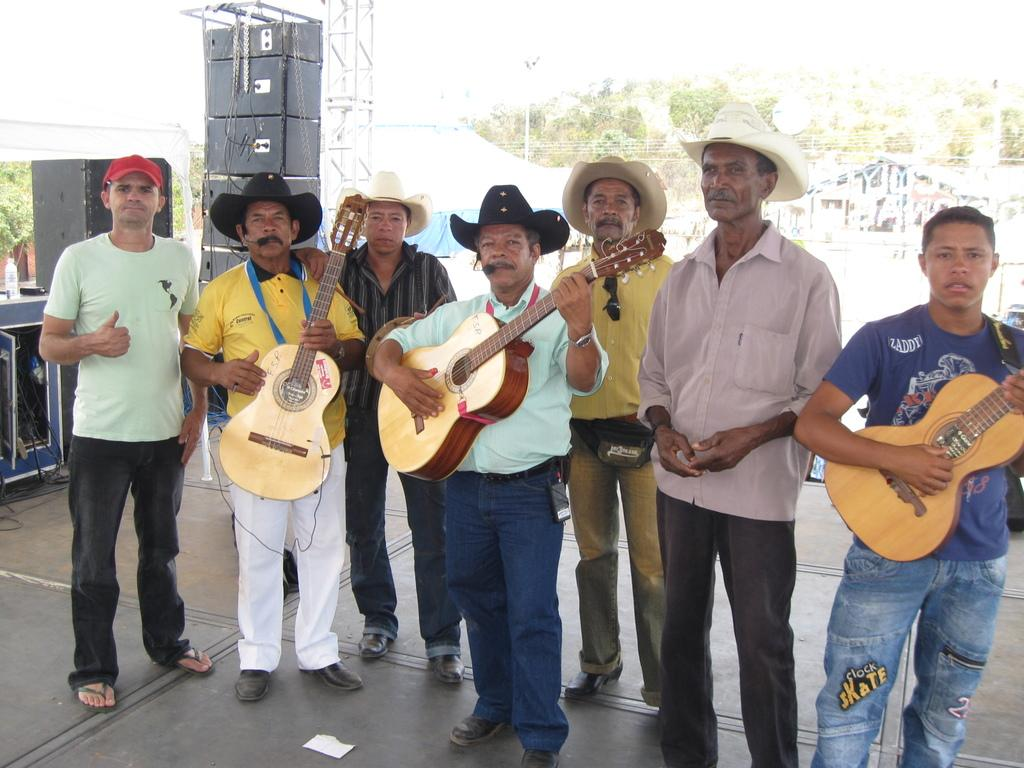How many people are in the image? There is a group of people in the image, but the exact number is not specified. What are the people doing in the image? The people are standing on the floor and holding a guitar in their hands. What can be seen in the background of the image? There are trees visible in the background of the image. Where is the board located in the image? There is no board present in the image. Can you see any hills in the background of the image? The provided facts do not mention any hills in the background of the image; only trees are mentioned. 